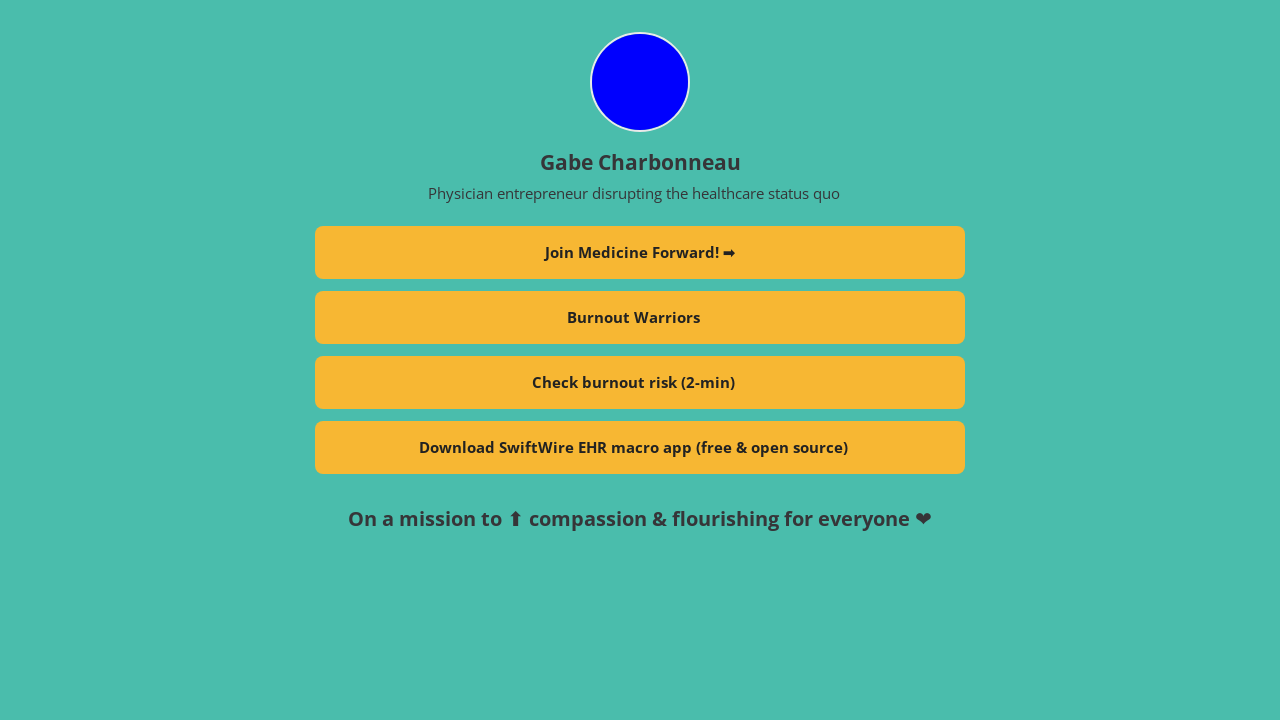What is the main goal of the 'Join Medicine Forward!' initiative mentioned on the profile? The 'Join Medicine Forward!' initiative aims to bring together healthcare professionals and enthusiasts to innovate and promote progressive changes in the medical field. It seeks to foster a community that collaborates on projects and ideas that can help improve patient care and the overall healthcare system. 